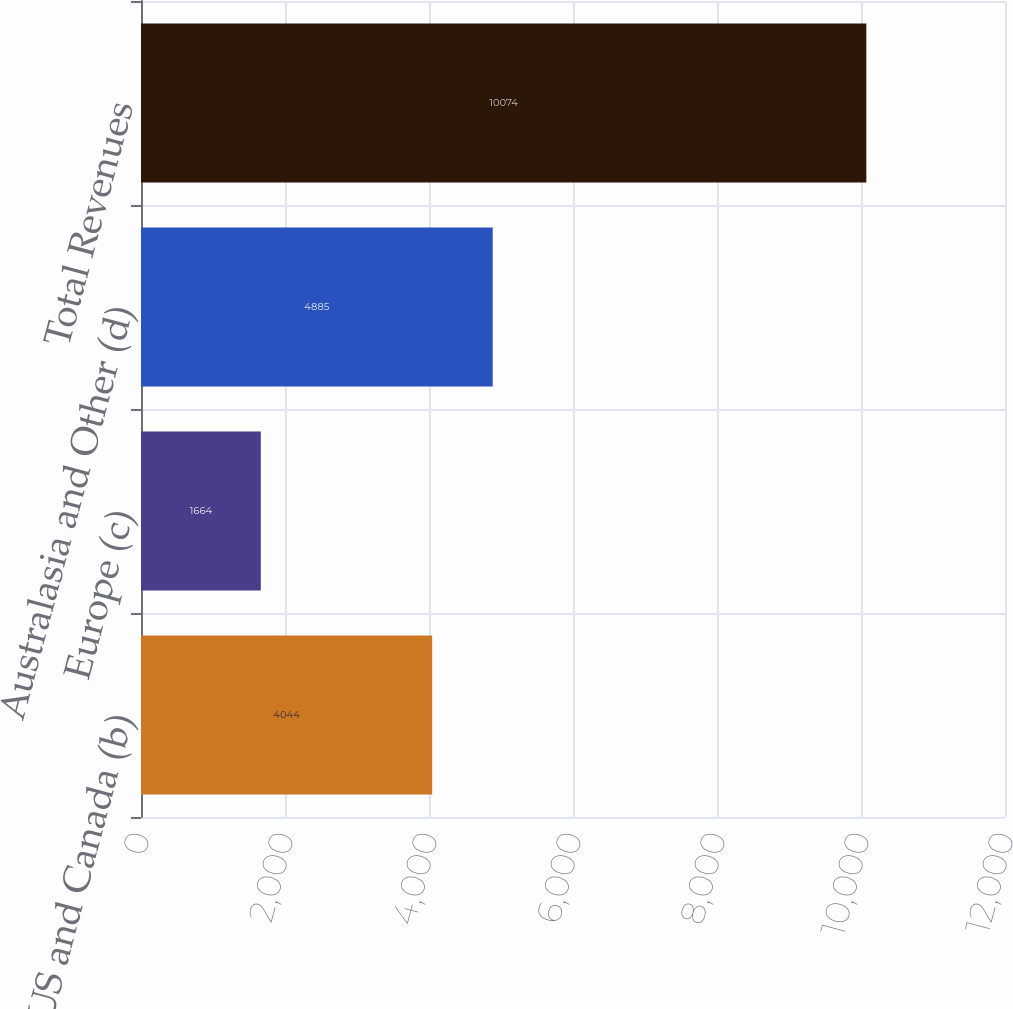Convert chart. <chart><loc_0><loc_0><loc_500><loc_500><bar_chart><fcel>US and Canada (b)<fcel>Europe (c)<fcel>Australasia and Other (d)<fcel>Total Revenues<nl><fcel>4044<fcel>1664<fcel>4885<fcel>10074<nl></chart> 